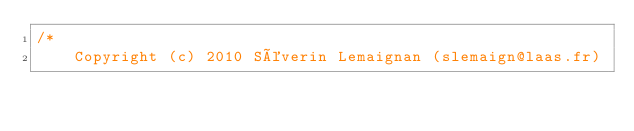<code> <loc_0><loc_0><loc_500><loc_500><_C_>/*
    Copyright (c) 2010 Séverin Lemaignan (slemaign@laas.fr)</code> 